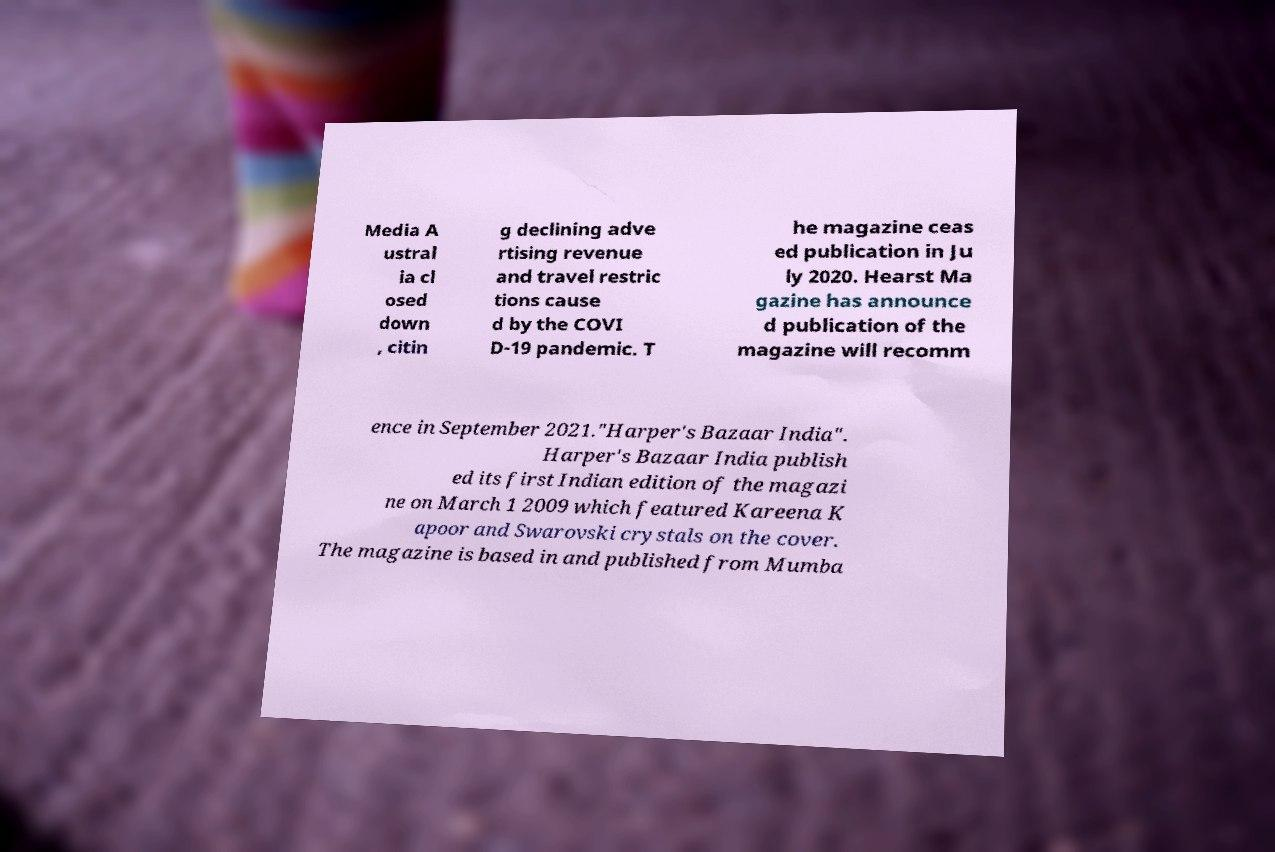Please identify and transcribe the text found in this image. Media A ustral ia cl osed down , citin g declining adve rtising revenue and travel restric tions cause d by the COVI D-19 pandemic. T he magazine ceas ed publication in Ju ly 2020. Hearst Ma gazine has announce d publication of the magazine will recomm ence in September 2021."Harper's Bazaar India". Harper's Bazaar India publish ed its first Indian edition of the magazi ne on March 1 2009 which featured Kareena K apoor and Swarovski crystals on the cover. The magazine is based in and published from Mumba 